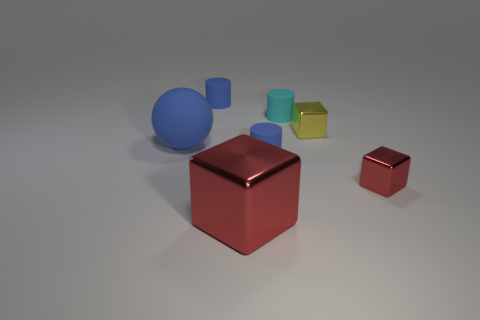Subtract all small blue matte cylinders. How many cylinders are left? 1 Add 1 tiny red rubber balls. How many objects exist? 8 Subtract all purple cubes. How many blue cylinders are left? 2 Subtract all blue cylinders. How many cylinders are left? 1 Subtract all cubes. How many objects are left? 4 Add 7 brown things. How many brown things exist? 7 Subtract 0 gray cylinders. How many objects are left? 7 Subtract 1 spheres. How many spheres are left? 0 Subtract all cyan spheres. Subtract all red cylinders. How many spheres are left? 1 Subtract all small cyan things. Subtract all large blue things. How many objects are left? 5 